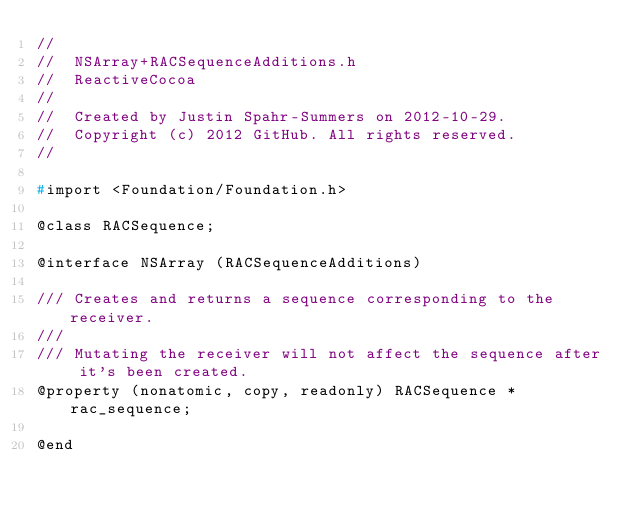Convert code to text. <code><loc_0><loc_0><loc_500><loc_500><_C_>//
//  NSArray+RACSequenceAdditions.h
//  ReactiveCocoa
//
//  Created by Justin Spahr-Summers on 2012-10-29.
//  Copyright (c) 2012 GitHub. All rights reserved.
//

#import <Foundation/Foundation.h>

@class RACSequence;

@interface NSArray (RACSequenceAdditions)

/// Creates and returns a sequence corresponding to the receiver.
///
/// Mutating the receiver will not affect the sequence after it's been created.
@property (nonatomic, copy, readonly) RACSequence *rac_sequence;

@end
</code> 